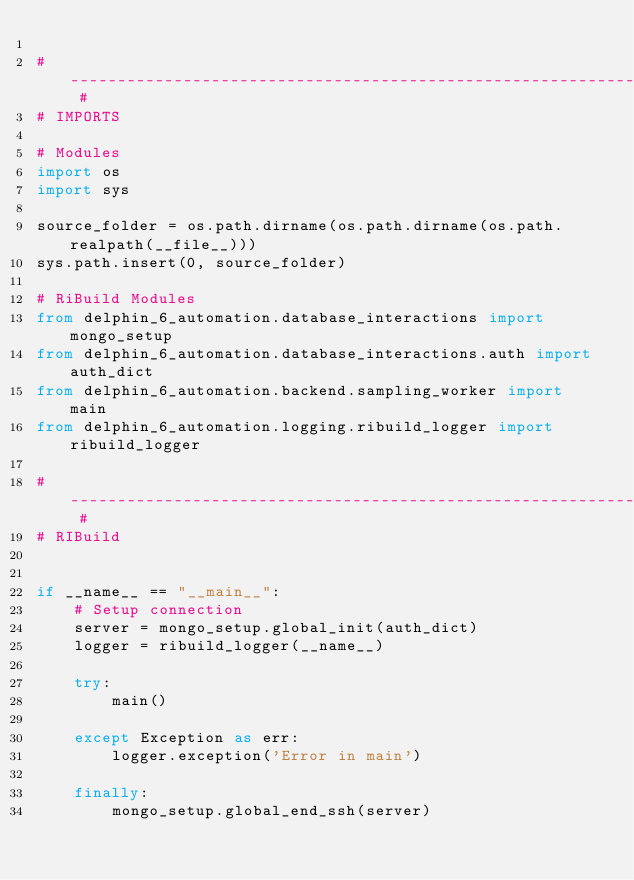<code> <loc_0><loc_0><loc_500><loc_500><_Python_>
# -------------------------------------------------------------------------------------------------------------------- #
# IMPORTS

# Modules
import os
import sys

source_folder = os.path.dirname(os.path.dirname(os.path.realpath(__file__)))
sys.path.insert(0, source_folder)

# RiBuild Modules
from delphin_6_automation.database_interactions import mongo_setup
from delphin_6_automation.database_interactions.auth import auth_dict
from delphin_6_automation.backend.sampling_worker import main
from delphin_6_automation.logging.ribuild_logger import ribuild_logger

# -------------------------------------------------------------------------------------------------------------------- #
# RIBuild


if __name__ == "__main__":
    # Setup connection
    server = mongo_setup.global_init(auth_dict)
    logger = ribuild_logger(__name__)

    try:
        main()

    except Exception as err:
        logger.exception('Error in main')

    finally:
        mongo_setup.global_end_ssh(server)
</code> 